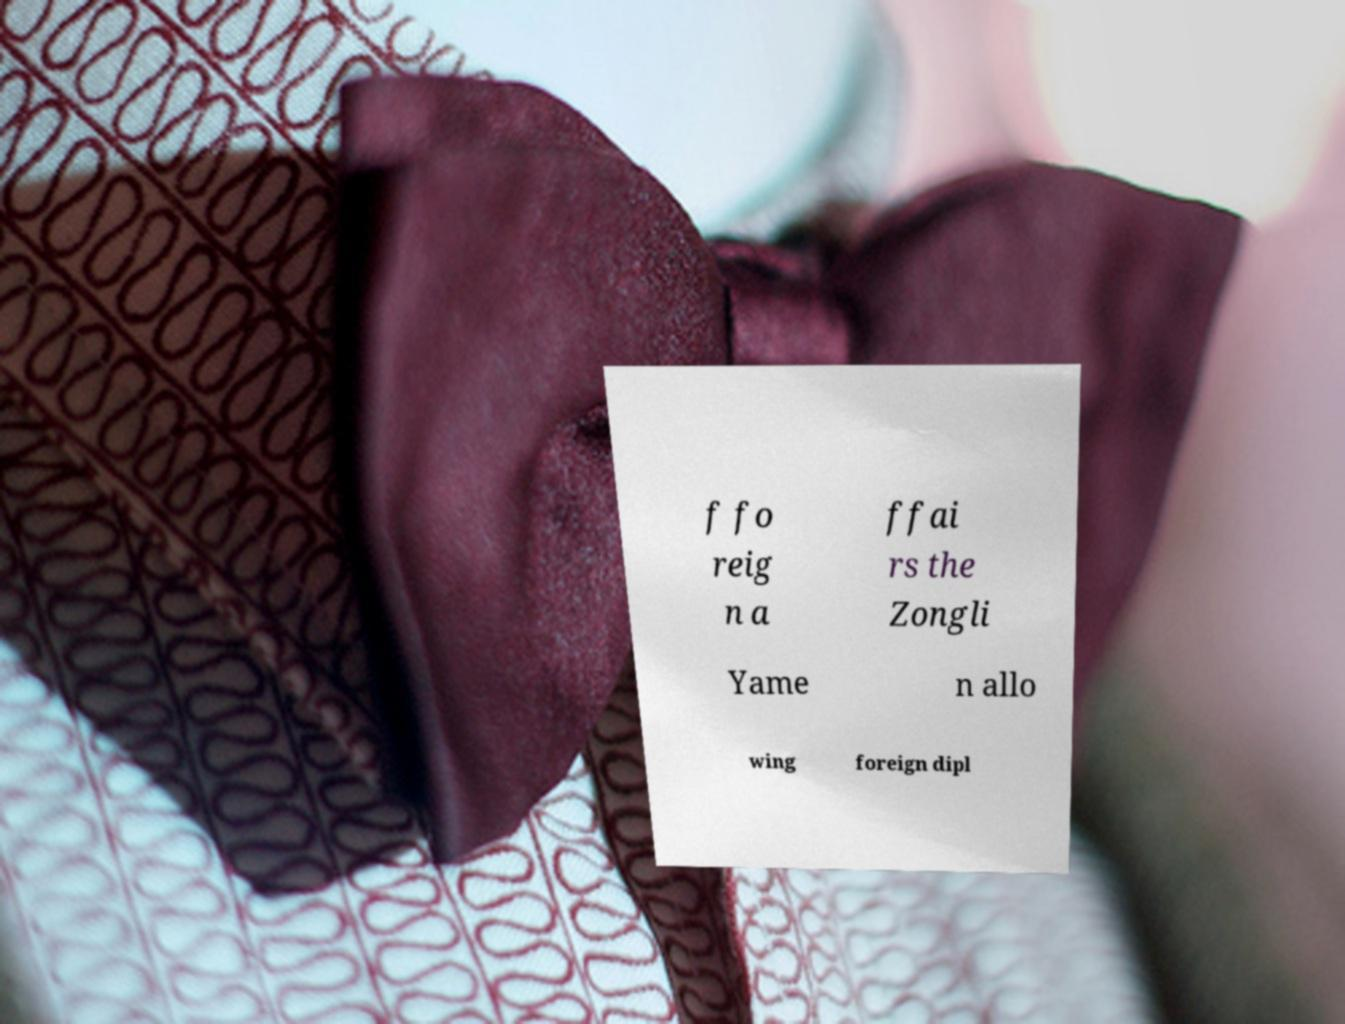Can you read and provide the text displayed in the image?This photo seems to have some interesting text. Can you extract and type it out for me? f fo reig n a ffai rs the Zongli Yame n allo wing foreign dipl 